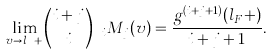<formula> <loc_0><loc_0><loc_500><loc_500>\lim _ { v \to l _ { F } + } { i + j \choose i } \ _ { i } M _ { j } ( v ) = \frac { g ^ { ( i + j + 1 ) } ( l _ { F } + ) } { i + j + 1 } .</formula> 